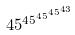Convert formula to latex. <formula><loc_0><loc_0><loc_500><loc_500>4 5 ^ { 4 5 ^ { 4 5 ^ { 4 5 ^ { 4 3 } } } }</formula> 